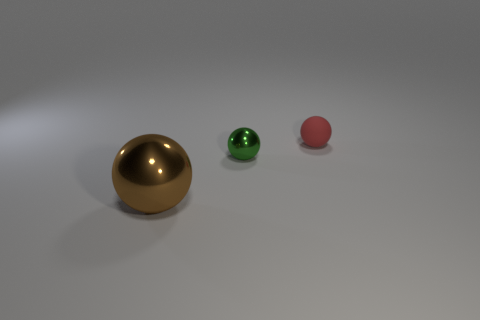Subtract 1 balls. How many balls are left? 2 Add 1 large shiny cubes. How many objects exist? 4 Add 3 tiny green metallic things. How many tiny green metallic things exist? 4 Subtract 0 red cubes. How many objects are left? 3 Subtract all brown metal spheres. Subtract all large red metal blocks. How many objects are left? 2 Add 1 small red things. How many small red things are left? 2 